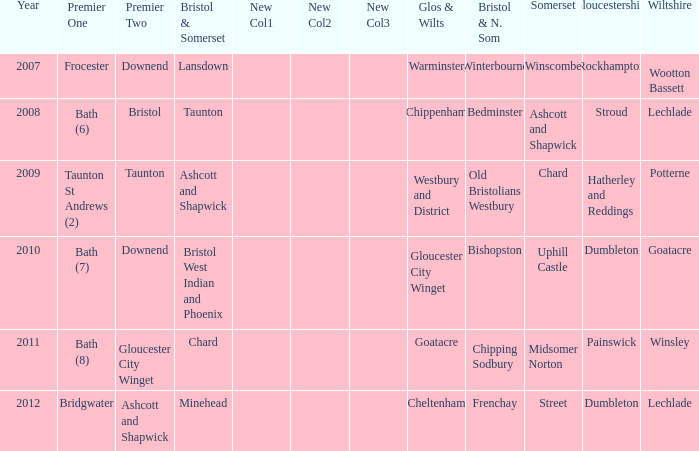What is the bristol & n. som where the somerset is ashcott and shapwick? Bedminster. 